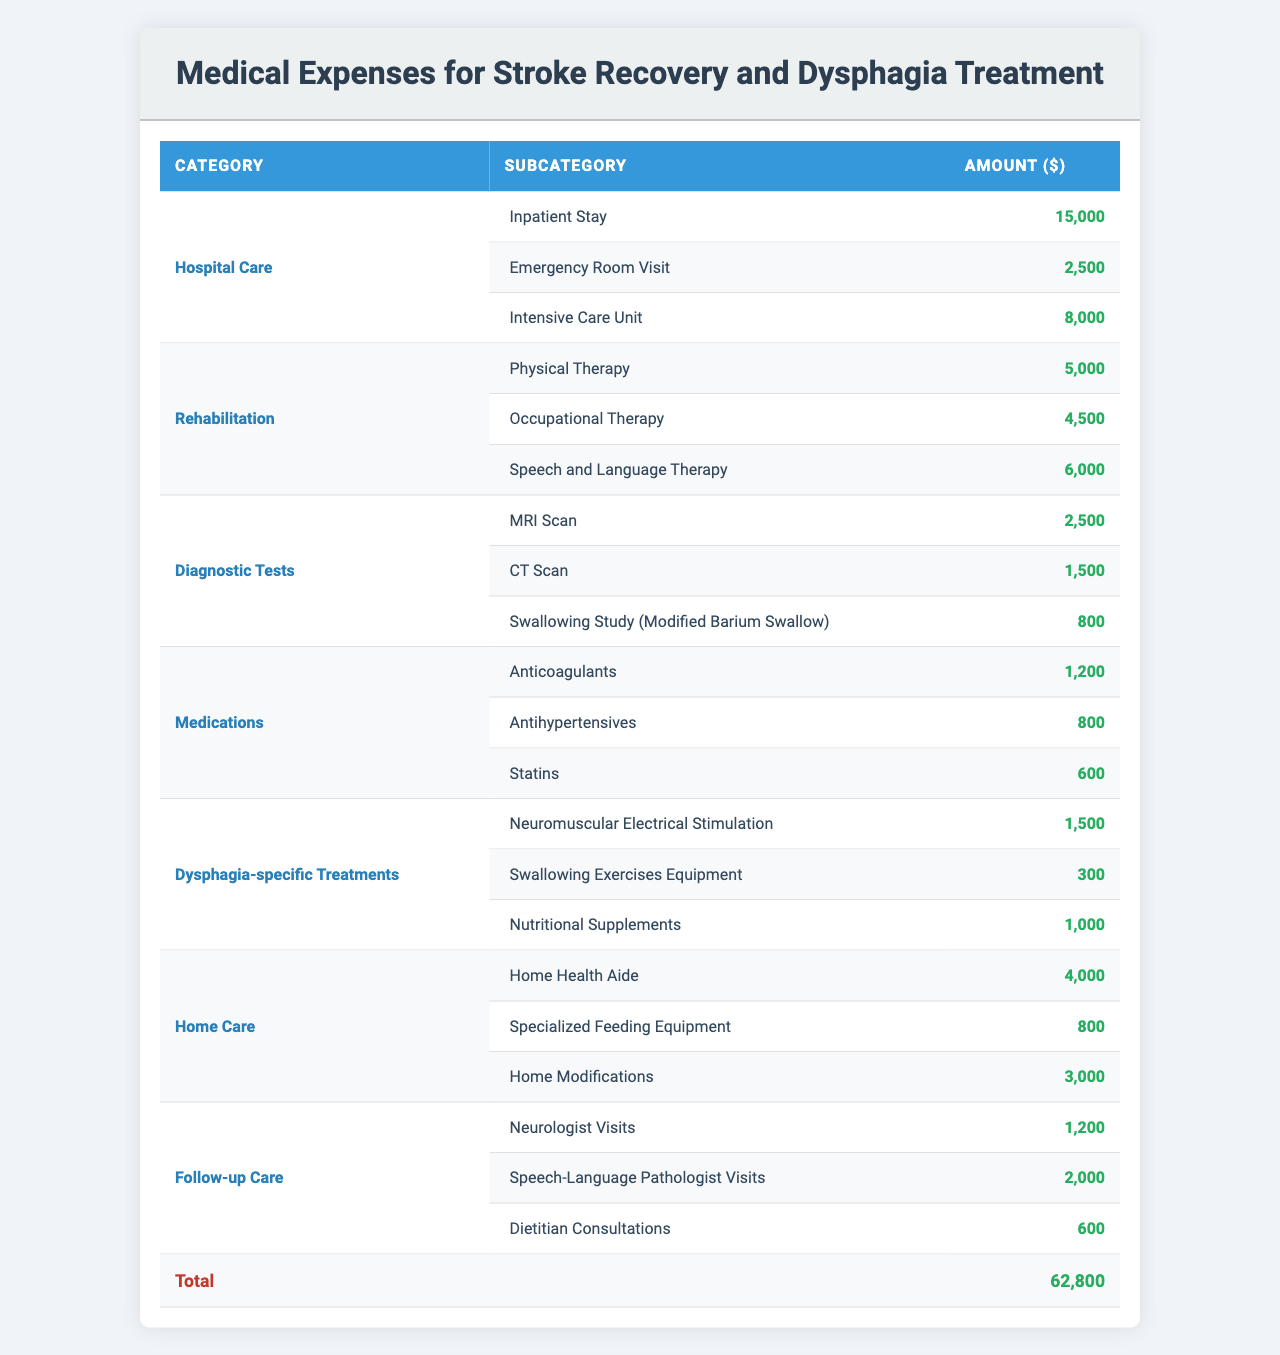What is the total cost of Hospital Care? The total cost for Hospital Care can be found by adding the costs for Inpatient Stay ($15,000), Emergency Room Visit ($2,500), and Intensive Care Unit ($8,000). The calculation is $15,000 + $2,500 + $8,000 = $25,500.
Answer: $25,500 How much does Rehabilitation cost in total? To find the total cost for Rehabilitation, add the costs of Physical Therapy ($5,000), Occupational Therapy ($4,500), and Speech and Language Therapy ($6,000). The total is $5,000 + $4,500 + $6,000 = $15,500.
Answer: $15,500 What is the cost of a CT Scan? The cost of a CT Scan is $1,500, as listed under the Diagnostic Tests section.
Answer: $1,500 Is the cost of Neuromuscular Electrical Stimulation higher than the cost of Anticoagulants? Neuromuscular Electrical Stimulation costs $1,500 and Anticoagulants cost $1,200. Since $1,500 is greater than $1,200, the statement is true.
Answer: Yes What is the combined cost of Home Care treatments? The combined cost is found by adding Home Health Aide ($4,000), Specialized Feeding Equipment ($800), and Home Modifications ($3,000). The total is $4,000 + $800 + $3,000 = $7,800.
Answer: $7,800 Which rehabilitation therapy costs the most? Comparing the costs: Physical Therapy ($5,000), Occupational Therapy ($4,500), and Speech and Language Therapy ($6,000), Speech and Language Therapy has the highest cost at $6,000.
Answer: Speech and Language Therapy What is the total cost of Dysphagia-specific Treatments? The total for Dysphagia-specific Treatments is calculated by adding Neuromuscular Electrical Stimulation ($1,500), Swallowing Exercises Equipment ($300), and Nutritional Supplements ($1,000). Therefore, the total is $1,500 + $300 + $1,000 = $2,800.
Answer: $2,800 What is the total amount spent on Follow-up Care? The total for Follow-up Care includes Neurologist Visits ($1,200), Speech-Language Pathologist Visits ($2,000), and Dietitian Consultations ($600). Thus, the total is $1,200 + $2,000 + $600 = $3,800.
Answer: $3,800 If I consider all medical expenses, what is the overall total? The overall total is calculated by adding all category totals: Hospital Care ($25,500) + Rehabilitation ($15,500) + Diagnostic Tests ($4,800) + Medications ($2,600) + Dysphagia-specific Treatments ($2,800) + Home Care ($7,800) + Follow-up Care ($3,800). This sums to $25,500 + $15,500 + $4,800 + $2,600 + $2,800 + $7,800 + $3,800 = $62,800.
Answer: $62,800 Is the total cost of Medications more than $2,000? The total cost of Medications is $1,200 (Anticoagulants) + $800 (Antihypertensives) + $600 (Statins) = $2,600. Since $2,600 is greater than $2,000, the answer is yes.
Answer: Yes 